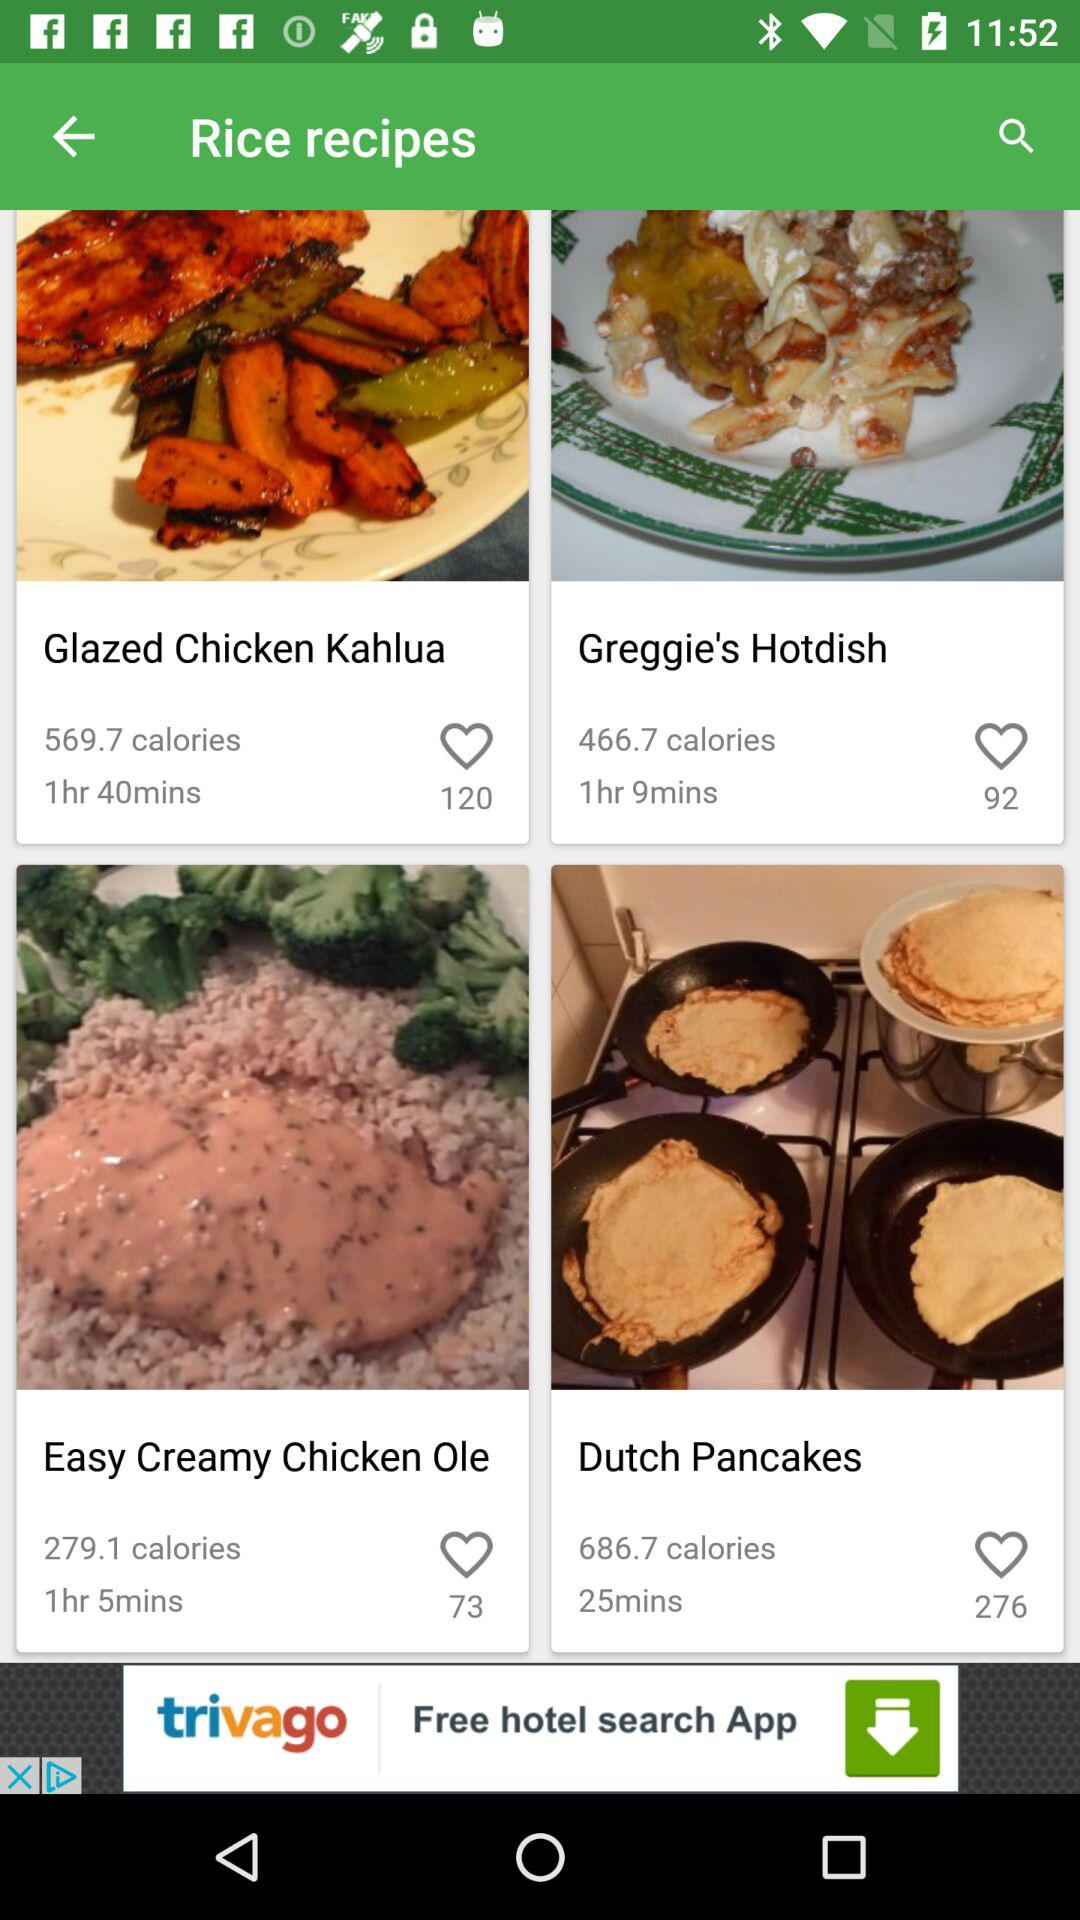How many calories are in "Easy Creamy Chicken Ole"? There are 279.1 calories in "Easy Creamy Chicken Ole". 